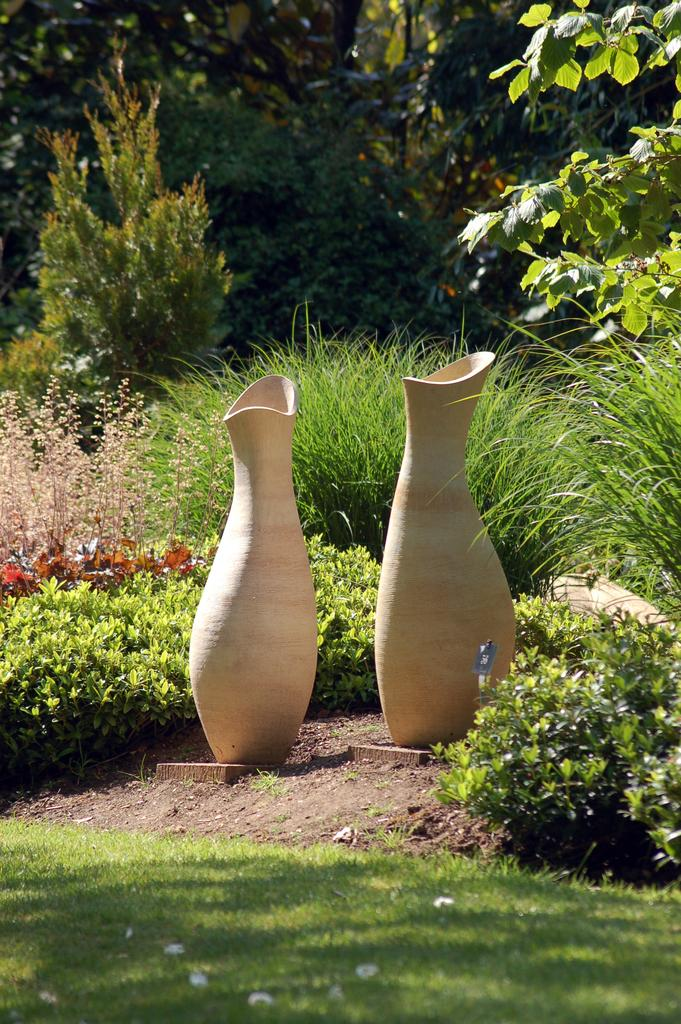What type of vegetation is visible in the image? There is grass and plants visible in the image. What objects are on the ground in the image? There are pots on the ground in the image. What can be seen in the background of the image? There are trees in the background of the image. What shape is the bit of grass in the image? There is no bit of grass mentioned in the image, and the shape of the grass cannot be determined from the image. Is the grass in the image arranged in a square pattern? The grass in the image is not arranged in any specific pattern, and there is no mention of a square arrangement. 